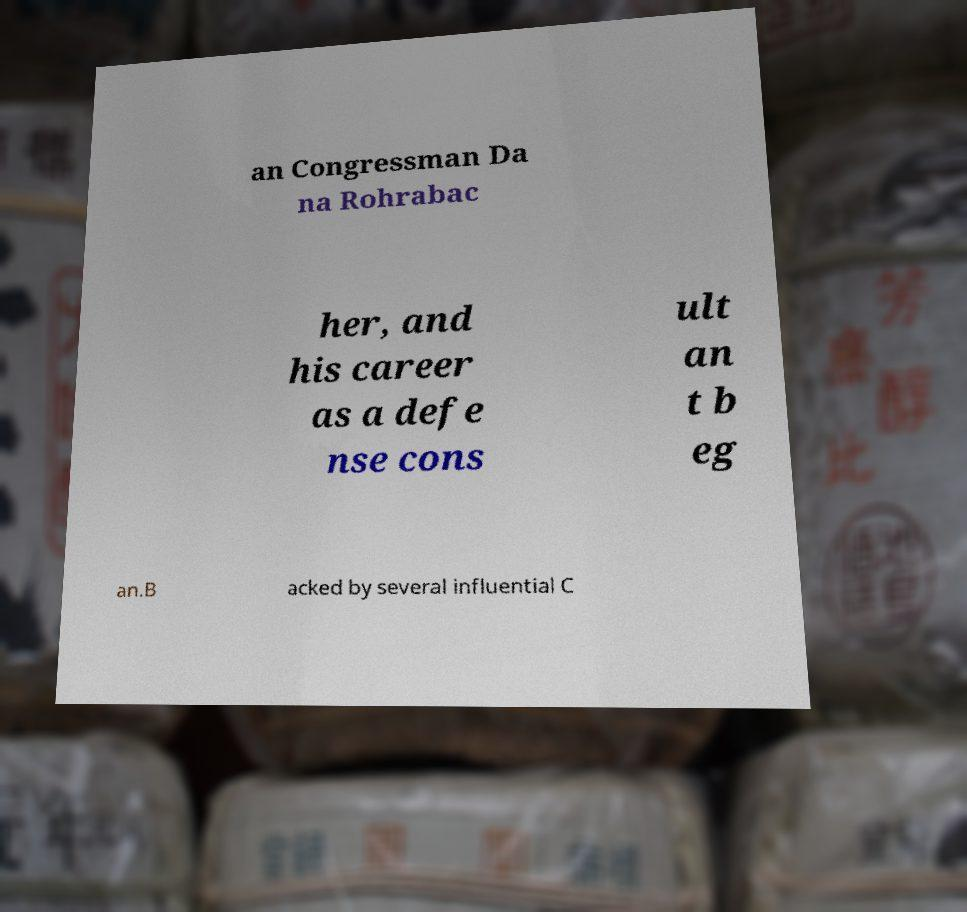Please identify and transcribe the text found in this image. an Congressman Da na Rohrabac her, and his career as a defe nse cons ult an t b eg an.B acked by several influential C 